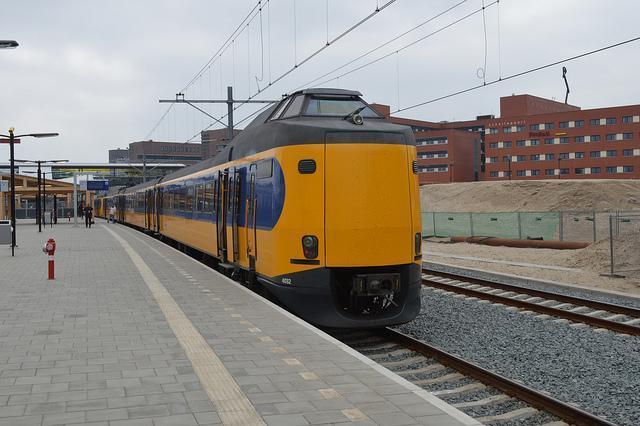How many tracks are seen?
Give a very brief answer. 2. 